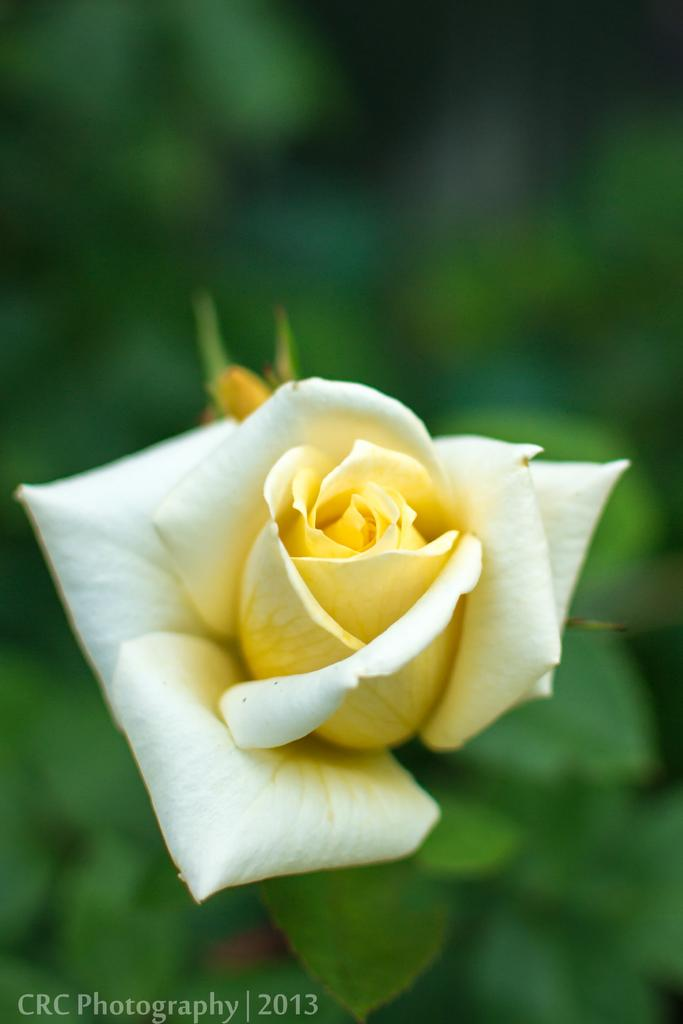What can be found in the bottom left corner of the image? There is a watermark on the bottom left of the image. What is the main subject of the image? The main subject of the image is a yellow color rose flower in the middle of the image. How would you describe the background of the image? The background of the image is blurred. How many mice are sitting on the yellow rose flower in the image? There are no mice present in the image; it features a yellow rose flower with a blurred background. What type of bean is growing next to the yellow rose flower in the image? There is no bean present in the image; it only features a yellow rose flower and a blurred background. 